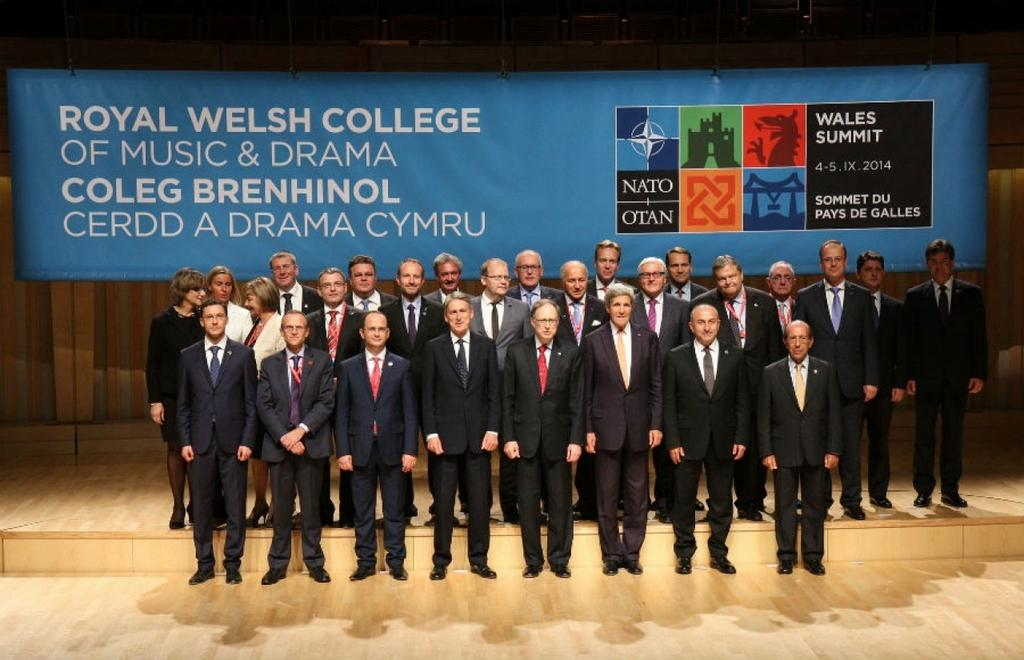What can be seen in the image? There are people standing in the image. Where are the people standing? The people are standing on the floor. What are the people wearing? The people are wearing coats. What color is the flex in the background of the image? There is a blue color flex in the background of the image. Can you see any pickles in the image? There are no pickles present in the image. 